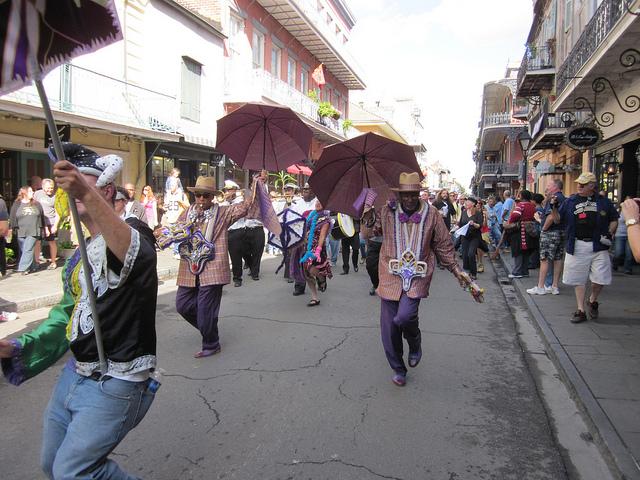What region is the photo likely to be from?
Concise answer only. New orleans. Is the image in black and white?
Answer briefly. No. How many blue shirts can you spot in the photo?
Short answer required. 2. Which festival is this?
Be succinct. Mardi gras. What is the colors of the umbrellas?
Answer briefly. Purple. Is it taken in a park?
Quick response, please. No. What is the people holding in their hands?
Concise answer only. Umbrellas. What is the occupation of the man in the brown?
Answer briefly. Dancer. 